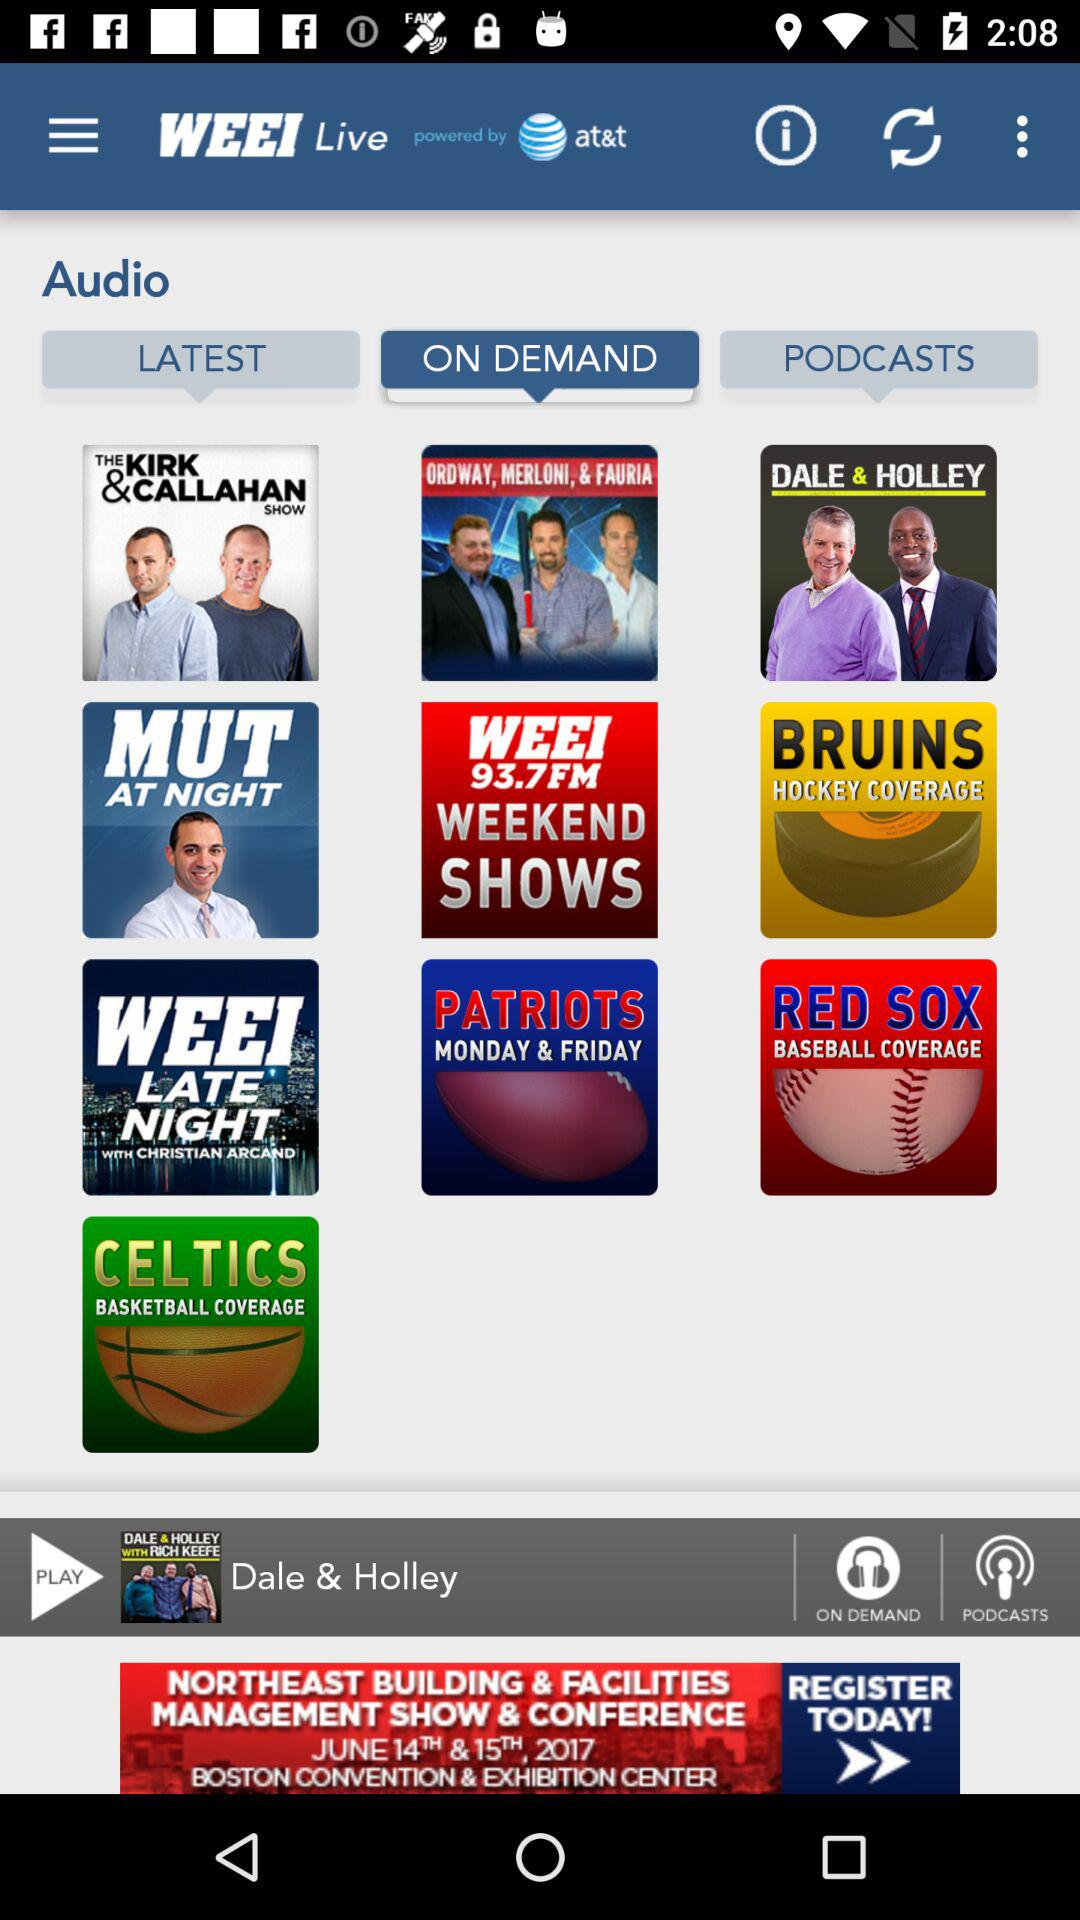Which tab is selected? The selected tab is "ON DEMAND". 